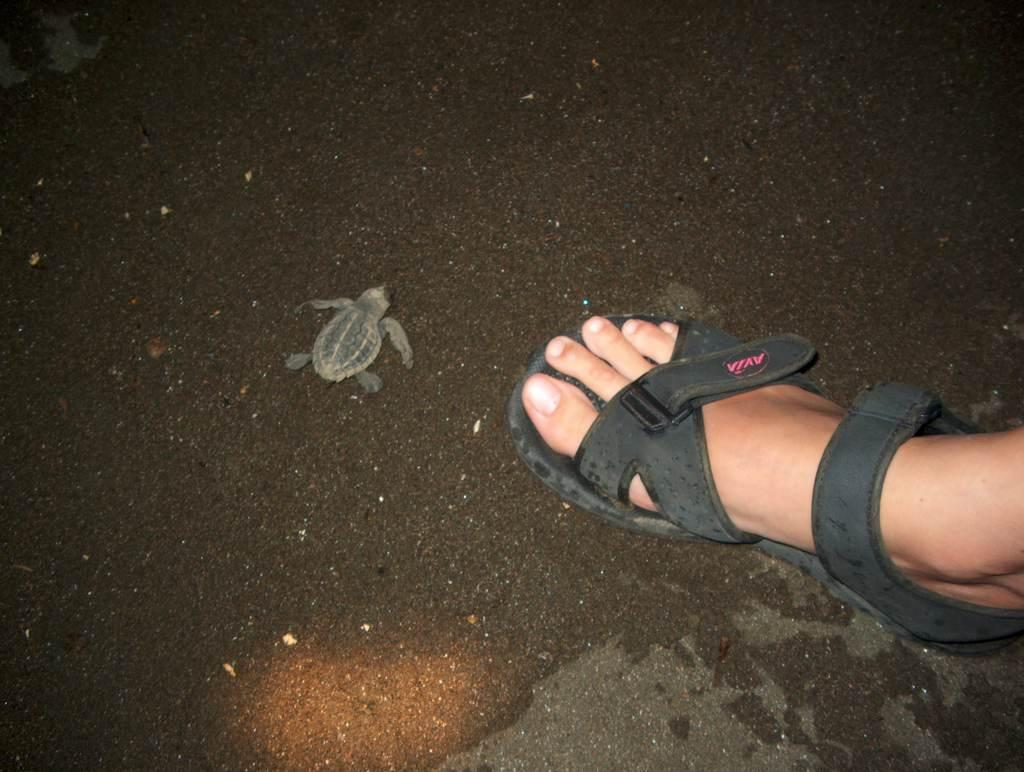What type of animal is in the image? There is a turtle in the image. Can you describe any human presence in the image? There is a person's leg visible in the image. What is on the person's foot in the image? The person's leg has footwear on it. Where is the person's leg and footwear located in the image? The leg and footwear are on the ground in the image. How does the turtle grip the carriage in the image? There is no carriage present in the image, and the turtle is not gripping anything. 